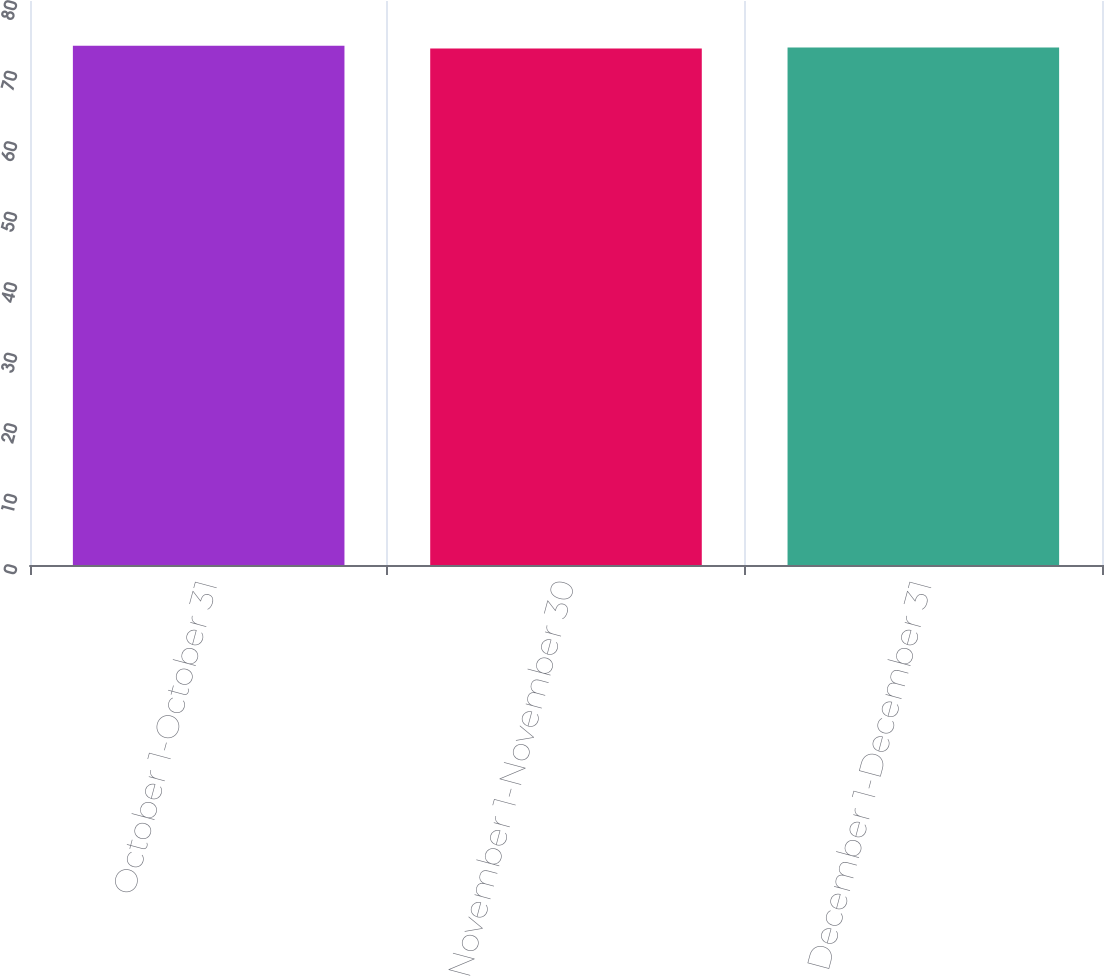Convert chart to OTSL. <chart><loc_0><loc_0><loc_500><loc_500><bar_chart><fcel>October 1-October 31<fcel>November 1-November 30<fcel>December 1-December 31<nl><fcel>73.64<fcel>73.26<fcel>73.4<nl></chart> 